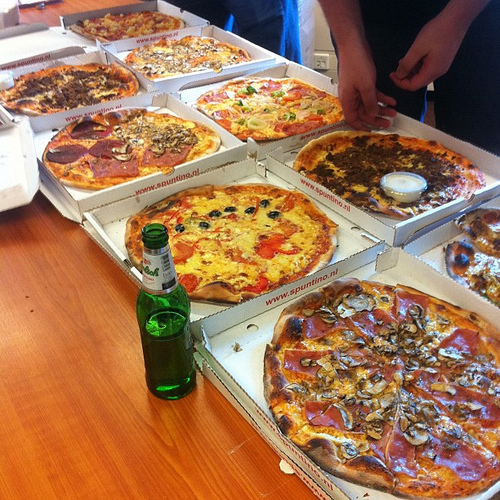Which kind of furniture is this, a bed or a table? This is a table. 